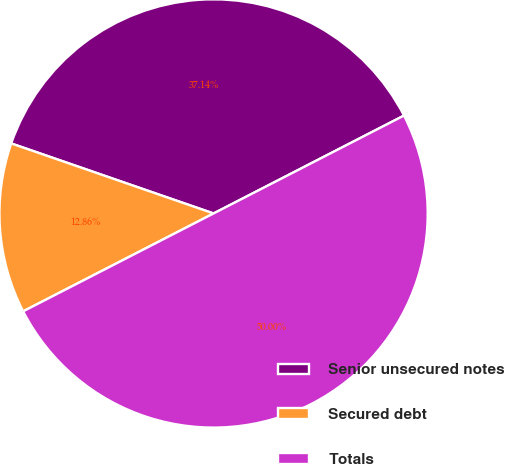Convert chart to OTSL. <chart><loc_0><loc_0><loc_500><loc_500><pie_chart><fcel>Senior unsecured notes<fcel>Secured debt<fcel>Totals<nl><fcel>37.14%<fcel>12.86%<fcel>50.0%<nl></chart> 